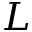<formula> <loc_0><loc_0><loc_500><loc_500>L</formula> 